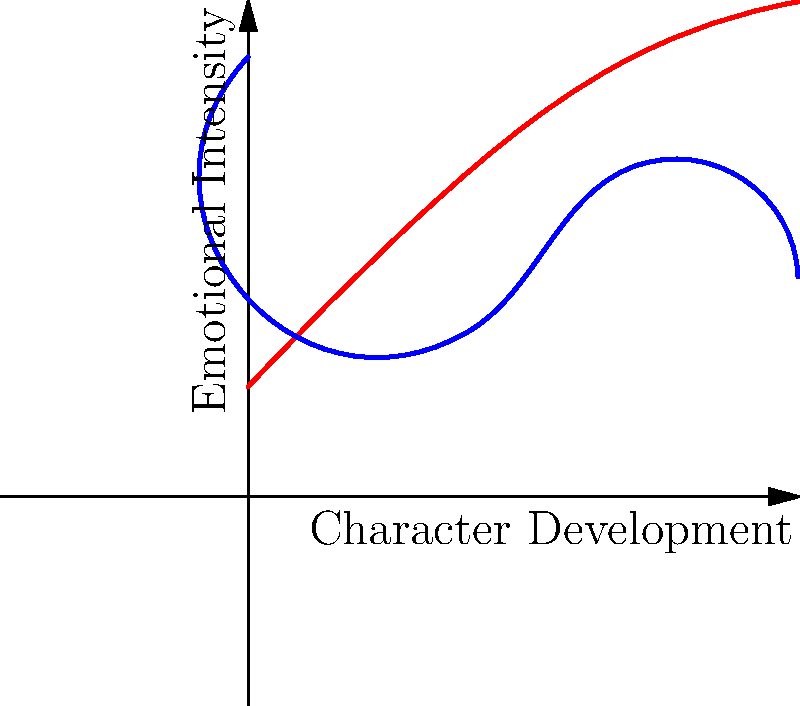In the coordinate system above, two character development arcs are plotted for a novel you're teaching. The x-axis represents the progression of the story, while the y-axis represents emotional intensity. Analyze the graph and explain how you would use this visual representation to teach students about narrative perspective and character development. How might the intersection point of these two arcs impact the story's narrative structure? To analyze this graph and use it for teaching narrative perspective and character development:

1. Identify the characters:
   - Red line represents Character A
   - Blue line represents Character B

2. Analyze starting points:
   - Character A starts at a lower emotional intensity
   - Character B starts at a higher emotional intensity

3. Trace the arcs:
   - Character A's emotional intensity gradually increases throughout the story
   - Character B's emotional intensity initially decreases, then rises, and finally decreases again

4. Identify the intersection point:
   - The arcs intersect at approximately the 2/3 point of the story

5. Interpret the intersection:
   - This could represent a pivotal moment where the characters' emotional states align
   - It might indicate a shared experience or a change in their relationship

6. Discuss narrative perspective:
   - The graph allows students to visualize how different characters experience the same events
   - It shows how perspective can change the emotional impact of a story

7. Examine character development:
   - Character A shows steady growth, possibly overcoming challenges
   - Character B's arc suggests a more complex journey, with highs and lows

8. Analyze narrative structure:
   - The intersection point could mark a climax or turning point in the story
   - The final emotional states of the characters might hint at the story's resolution

9. Encourage student interpretation:
   - Ask students to hypothesize about events that might cause these emotional changes
   - Discuss how different narrative perspectives might focus on different parts of these arcs

By using this visual representation, students can better understand the interplay between character development, emotional journeys, and narrative structure, enhancing their comprehension of complex storytelling techniques.
Answer: Visual aid for teaching narrative perspective, character development, and story structure through intersecting emotional arcs. 